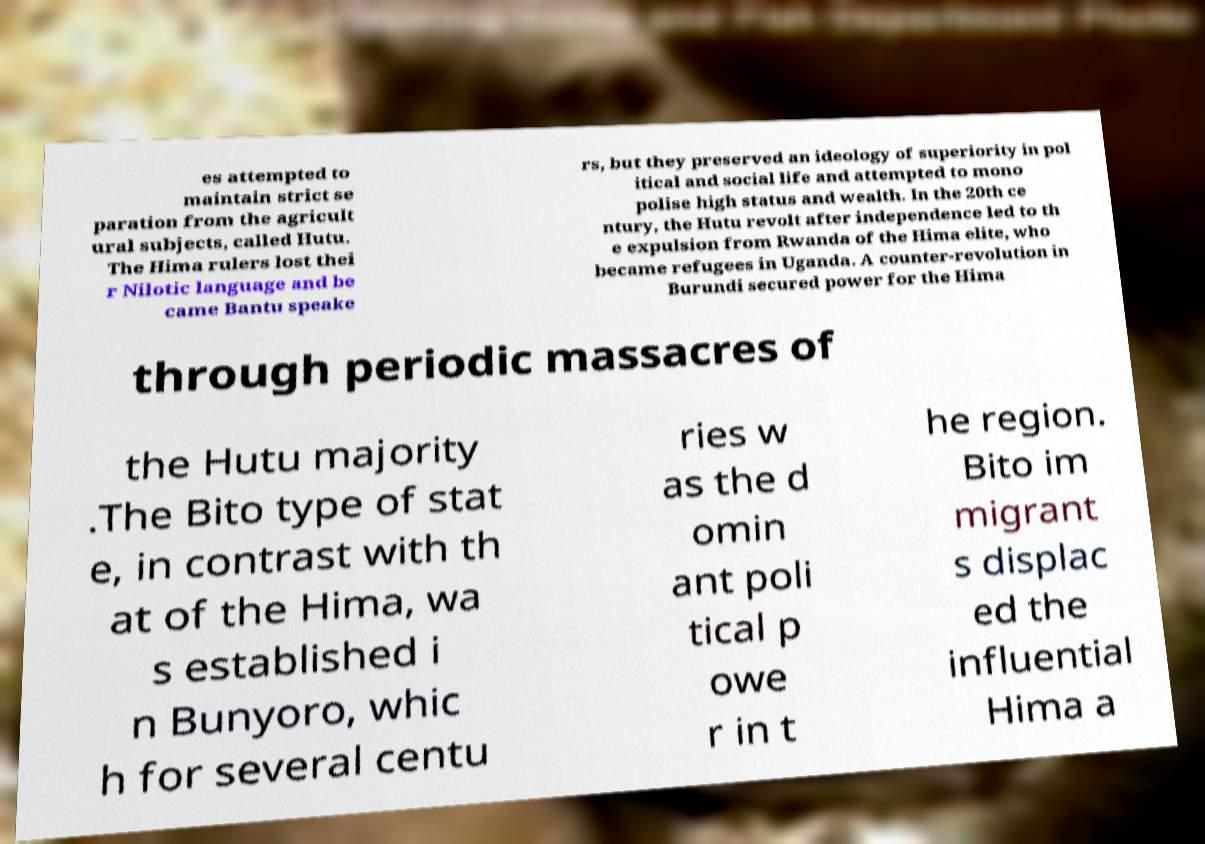There's text embedded in this image that I need extracted. Can you transcribe it verbatim? es attempted to maintain strict se paration from the agricult ural subjects, called Hutu. The Hima rulers lost thei r Nilotic language and be came Bantu speake rs, but they preserved an ideology of superiority in pol itical and social life and attempted to mono polise high status and wealth. In the 20th ce ntury, the Hutu revolt after independence led to th e expulsion from Rwanda of the Hima elite, who became refugees in Uganda. A counter-revolution in Burundi secured power for the Hima through periodic massacres of the Hutu majority .The Bito type of stat e, in contrast with th at of the Hima, wa s established i n Bunyoro, whic h for several centu ries w as the d omin ant poli tical p owe r in t he region. Bito im migrant s displac ed the influential Hima a 